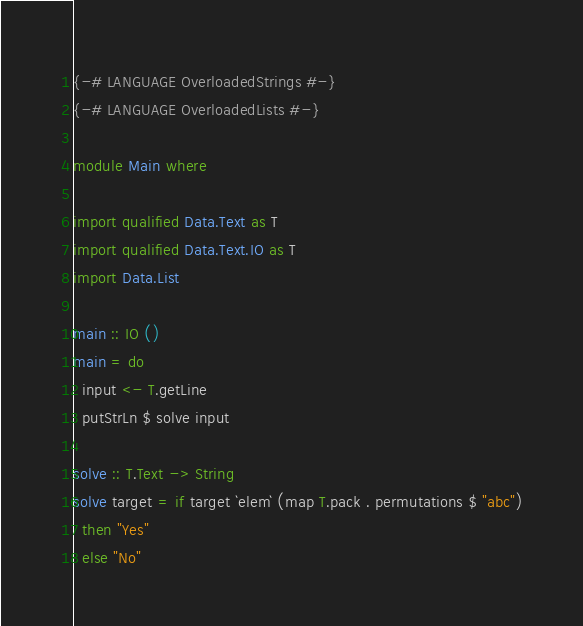Convert code to text. <code><loc_0><loc_0><loc_500><loc_500><_Haskell_>{-# LANGUAGE OverloadedStrings #-}
{-# LANGUAGE OverloadedLists #-}

module Main where

import qualified Data.Text as T
import qualified Data.Text.IO as T
import Data.List

main :: IO ()
main = do
  input <- T.getLine
  putStrLn $ solve input

solve :: T.Text -> String
solve target = if target `elem` (map T.pack . permutations $ "abc")
  then "Yes"
  else "No"
</code> 